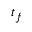<formula> <loc_0><loc_0><loc_500><loc_500>t _ { f }</formula> 